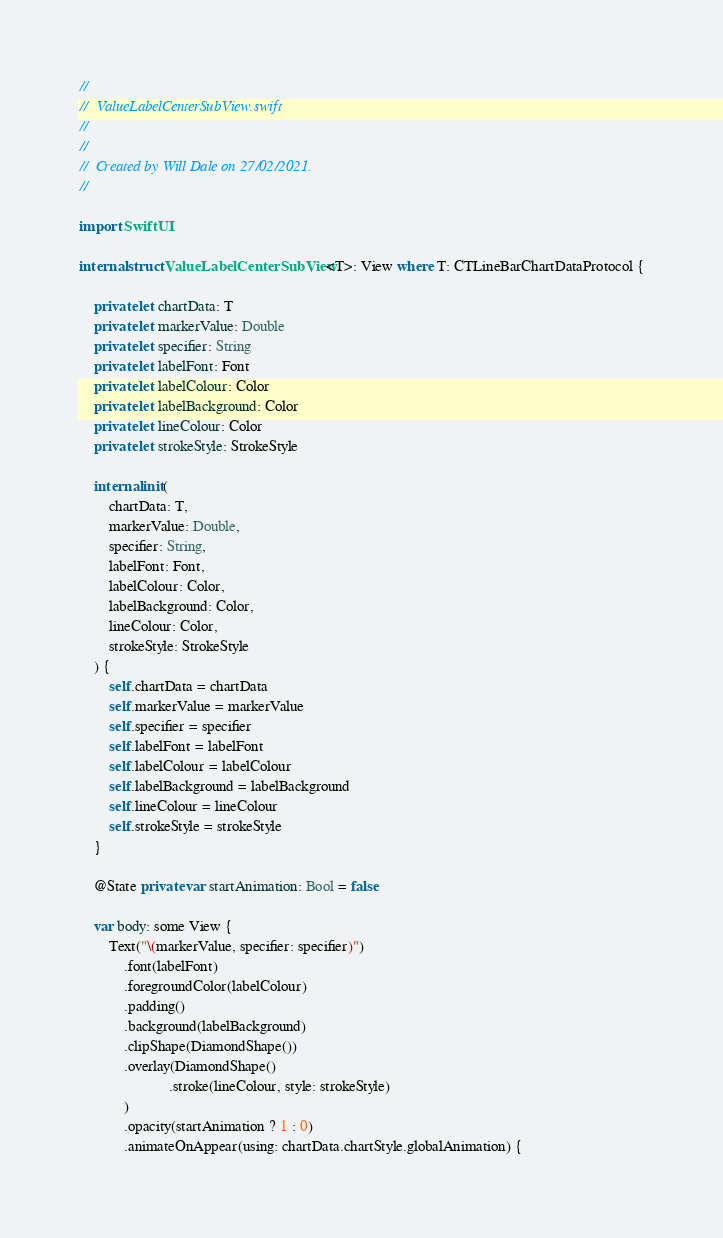Convert code to text. <code><loc_0><loc_0><loc_500><loc_500><_Swift_>//
//  ValueLabelCenterSubView.swift
//  
//
//  Created by Will Dale on 27/02/2021.
//

import SwiftUI

internal struct ValueLabelCenterSubView<T>: View where T: CTLineBarChartDataProtocol {
    
    private let chartData: T
    private let markerValue: Double
    private let specifier: String
    private let labelFont: Font
    private let labelColour: Color
    private let labelBackground: Color
    private let lineColour: Color
    private let strokeStyle: StrokeStyle
    
    internal init(
        chartData: T,
        markerValue: Double,
        specifier: String,
        labelFont: Font,
        labelColour: Color,
        labelBackground: Color,
        lineColour: Color,
        strokeStyle: StrokeStyle
    ) {
        self.chartData = chartData
        self.markerValue = markerValue
        self.specifier = specifier
        self.labelFont = labelFont
        self.labelColour = labelColour
        self.labelBackground = labelBackground
        self.lineColour = lineColour
        self.strokeStyle = strokeStyle
    }
    
    @State private var startAnimation: Bool = false
    
    var body: some View {
        Text("\(markerValue, specifier: specifier)")
            .font(labelFont)
            .foregroundColor(labelColour)
            .padding()
            .background(labelBackground)
            .clipShape(DiamondShape())
            .overlay(DiamondShape()
                        .stroke(lineColour, style: strokeStyle)
            )
            .opacity(startAnimation ? 1 : 0)
            .animateOnAppear(using: chartData.chartStyle.globalAnimation) {</code> 